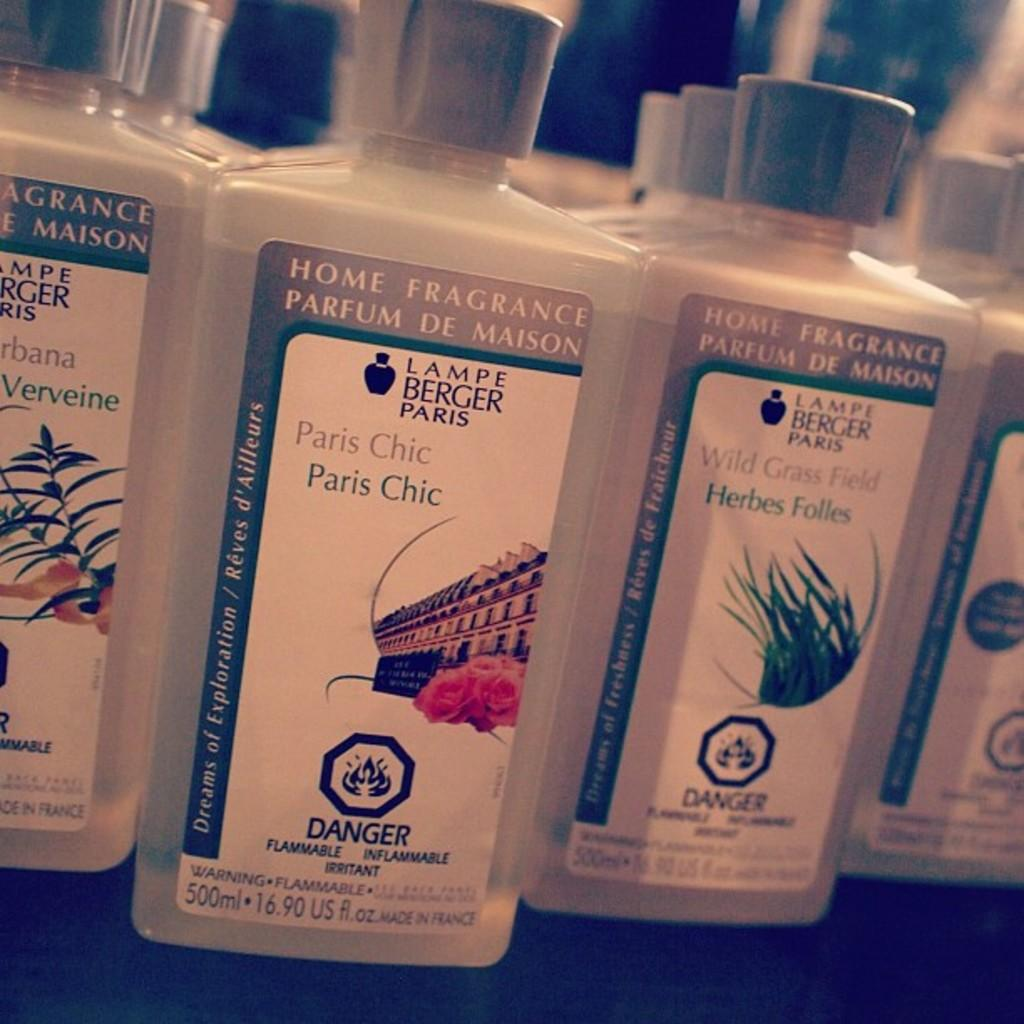<image>
Summarize the visual content of the image. different bottles of home fragrance in 500ml bottles 